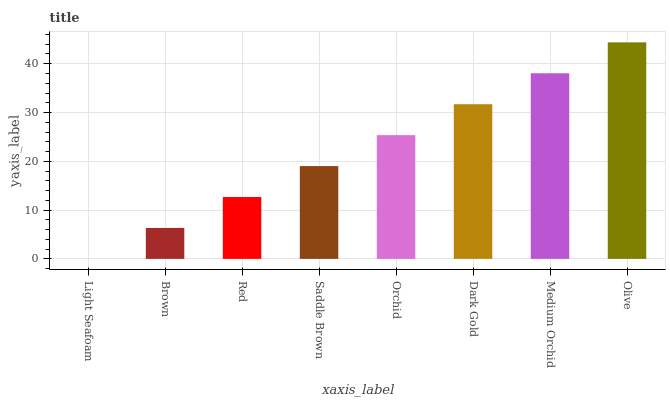Is Light Seafoam the minimum?
Answer yes or no. Yes. Is Olive the maximum?
Answer yes or no. Yes. Is Brown the minimum?
Answer yes or no. No. Is Brown the maximum?
Answer yes or no. No. Is Brown greater than Light Seafoam?
Answer yes or no. Yes. Is Light Seafoam less than Brown?
Answer yes or no. Yes. Is Light Seafoam greater than Brown?
Answer yes or no. No. Is Brown less than Light Seafoam?
Answer yes or no. No. Is Orchid the high median?
Answer yes or no. Yes. Is Saddle Brown the low median?
Answer yes or no. Yes. Is Saddle Brown the high median?
Answer yes or no. No. Is Red the low median?
Answer yes or no. No. 